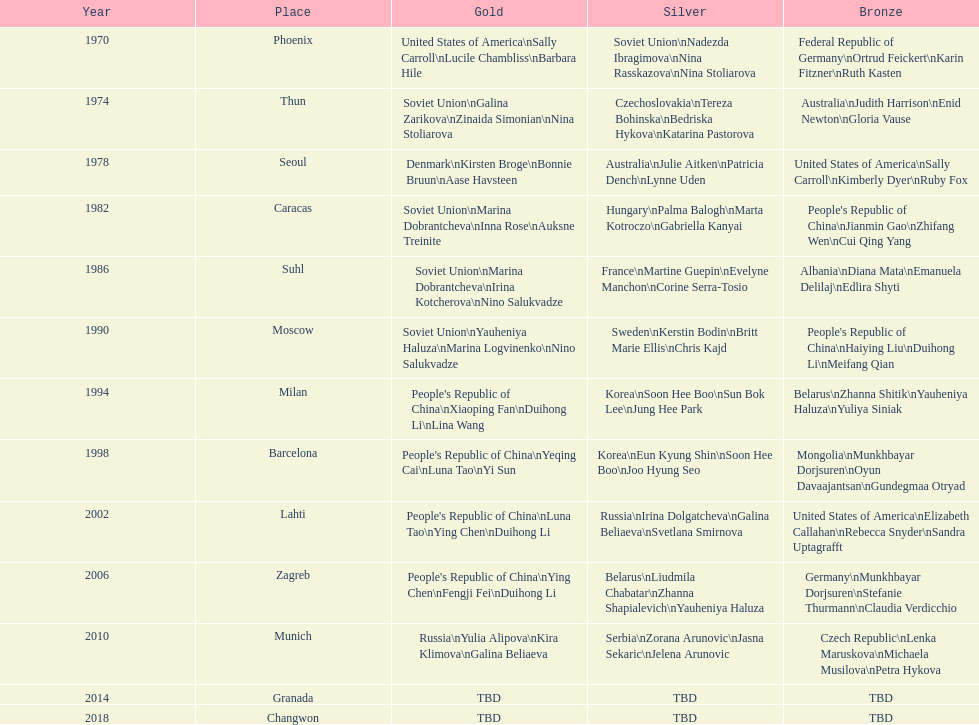In this chart, what is the topmost place listed? Phoenix. 